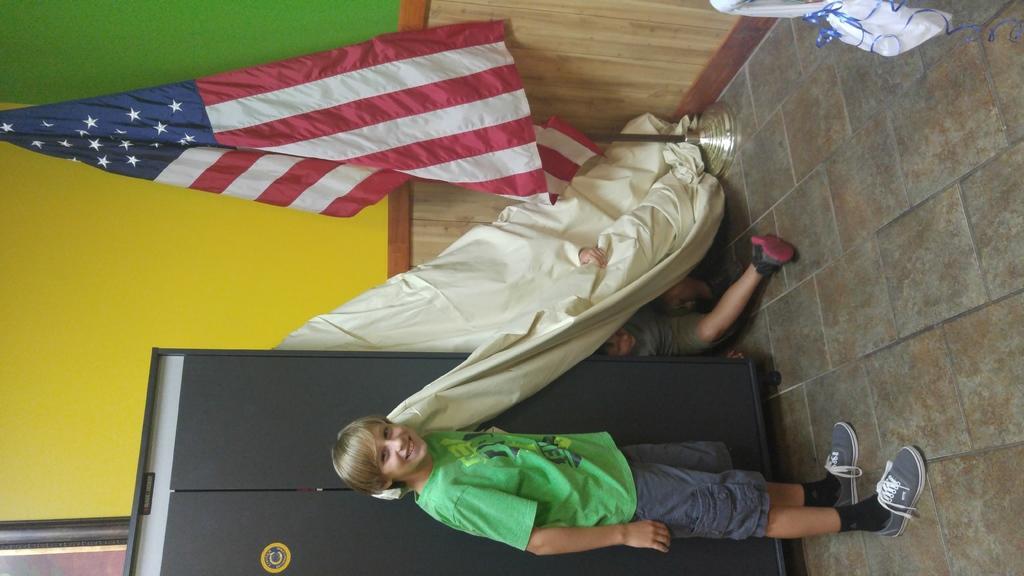Describe this image in one or two sentences. In this image, we can see a person standing and there is an other person hiding behind a curtain and we can see a flag, a cupboard and there is a frame on the wall and we can see a cover and some ribbons. At the bottom, there is a road. 